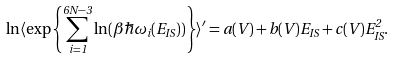Convert formula to latex. <formula><loc_0><loc_0><loc_500><loc_500>\ln \langle \exp \left \{ \sum _ { i = 1 } ^ { 6 N - 3 } \ln ( \beta \hbar { \omega } _ { i } ( E _ { I S } ) ) \right \} \rangle ^ { \prime } = a ( V ) + b ( V ) E _ { I S } + c ( V ) E _ { I S } ^ { 2 } .</formula> 